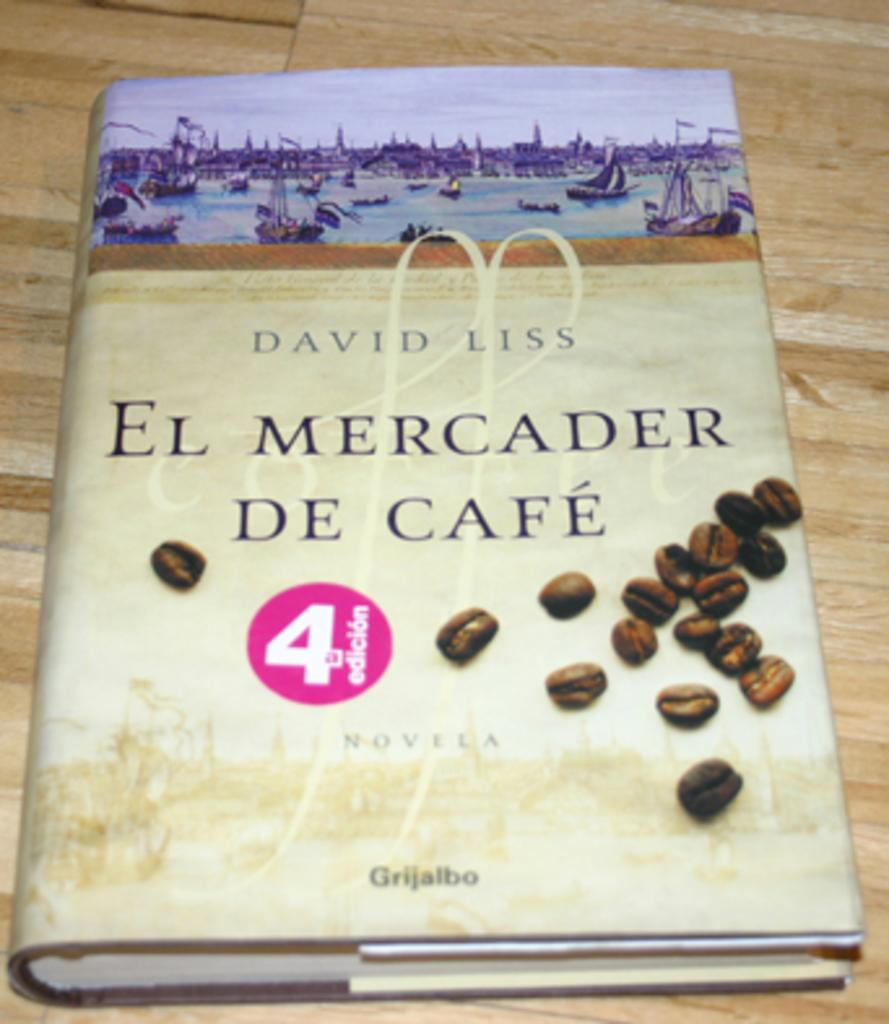<image>
Offer a succinct explanation of the picture presented. A Novela by David Liss called El Mercader De Cafe. 